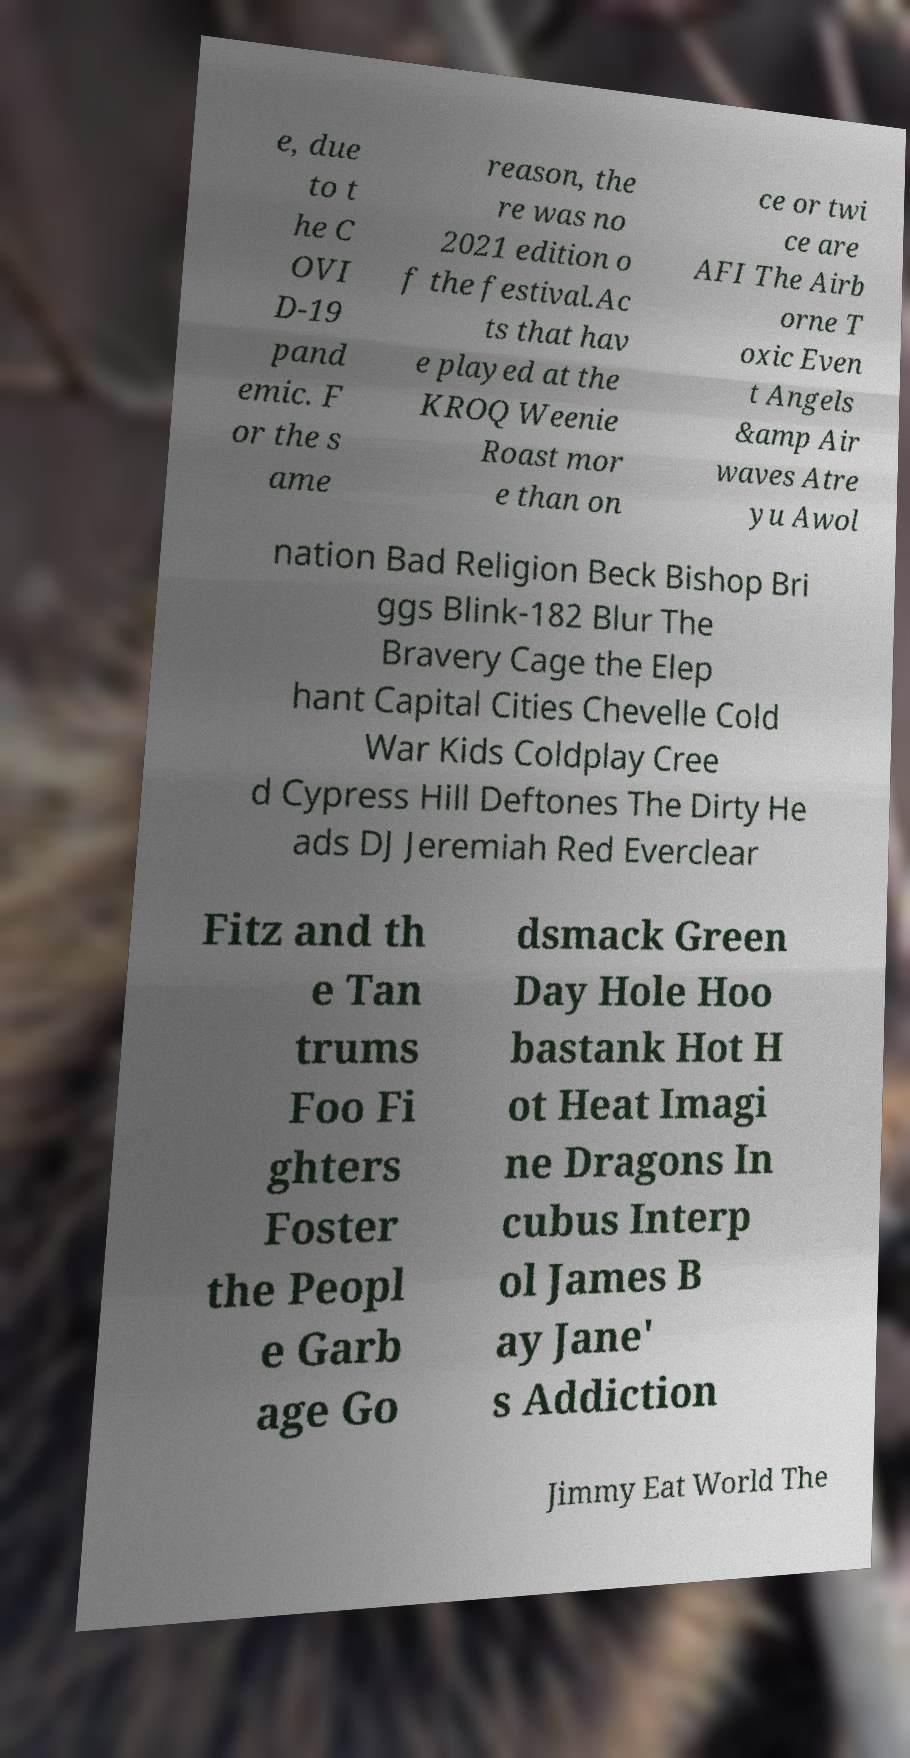I need the written content from this picture converted into text. Can you do that? e, due to t he C OVI D-19 pand emic. F or the s ame reason, the re was no 2021 edition o f the festival.Ac ts that hav e played at the KROQ Weenie Roast mor e than on ce or twi ce are AFI The Airb orne T oxic Even t Angels &amp Air waves Atre yu Awol nation Bad Religion Beck Bishop Bri ggs Blink-182 Blur The Bravery Cage the Elep hant Capital Cities Chevelle Cold War Kids Coldplay Cree d Cypress Hill Deftones The Dirty He ads DJ Jeremiah Red Everclear Fitz and th e Tan trums Foo Fi ghters Foster the Peopl e Garb age Go dsmack Green Day Hole Hoo bastank Hot H ot Heat Imagi ne Dragons In cubus Interp ol James B ay Jane' s Addiction Jimmy Eat World The 